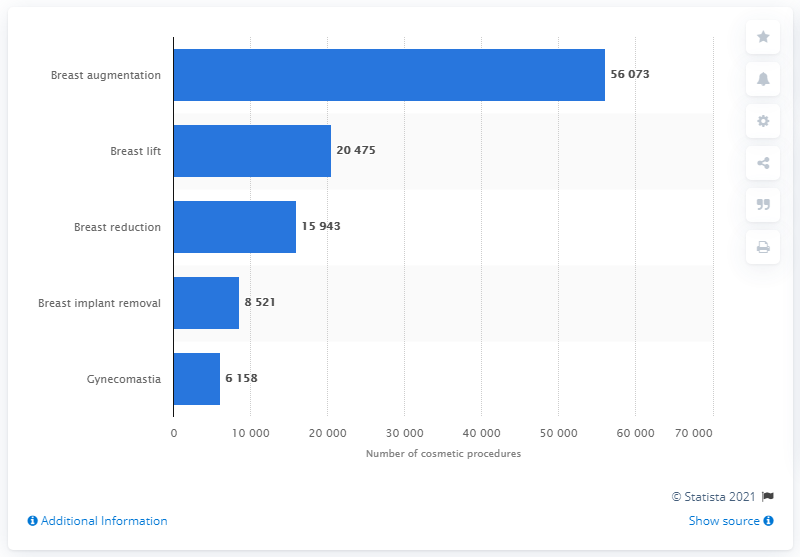Identify some key points in this picture. In 2019, a total of 56,073 breast cosmetic procedures were performed in Italy. 